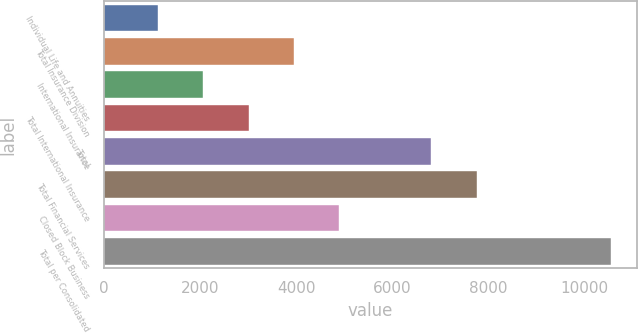Convert chart to OTSL. <chart><loc_0><loc_0><loc_500><loc_500><bar_chart><fcel>Individual Life and Annuities<fcel>Total Insurance Division<fcel>International Insurance<fcel>Total International Insurance<fcel>Total<fcel>Total Financial Services<fcel>Closed Block Business<fcel>Total per Consolidated<nl><fcel>1118<fcel>3950.6<fcel>2062.2<fcel>3006.4<fcel>6810<fcel>7754.2<fcel>4894.8<fcel>10560<nl></chart> 